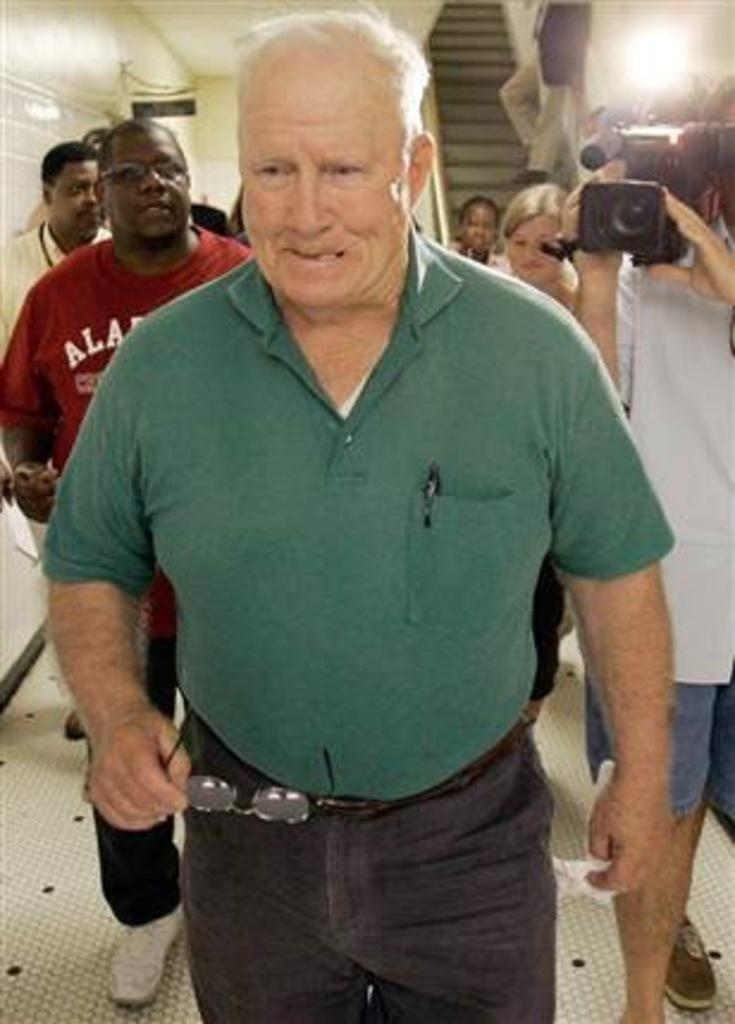How would you summarize this image in a sentence or two? In this image i can see a man walking he is holding the spectacles back of the man there is other man holding the camera,at the back ground there are few other persons standing there are stairs at the back. 